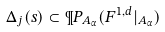Convert formula to latex. <formula><loc_0><loc_0><loc_500><loc_500>\Delta _ { j } ( s ) \subset \P P _ { A _ { \alpha } } ( F ^ { 1 , d } | _ { A _ { \alpha } } )</formula> 